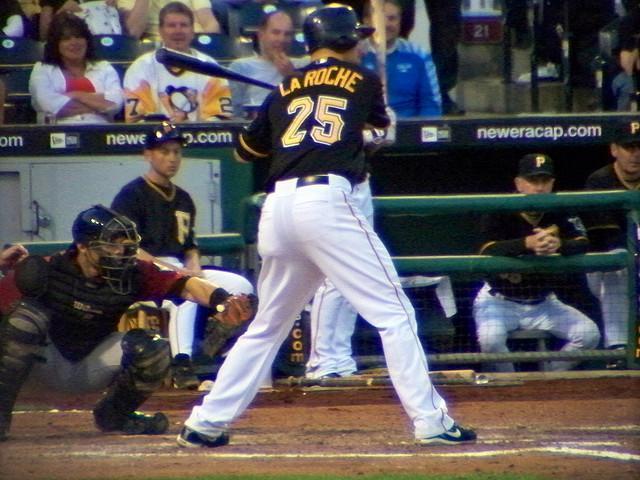How many people are visible?
Give a very brief answer. 10. How many zebras are in the pic?
Give a very brief answer. 0. 